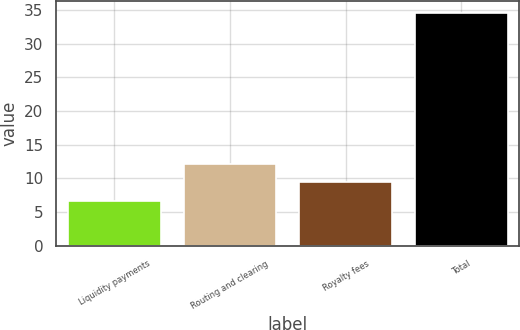Convert chart to OTSL. <chart><loc_0><loc_0><loc_500><loc_500><bar_chart><fcel>Liquidity payments<fcel>Routing and clearing<fcel>Royalty fees<fcel>Total<nl><fcel>6.6<fcel>12.2<fcel>9.4<fcel>34.6<nl></chart> 